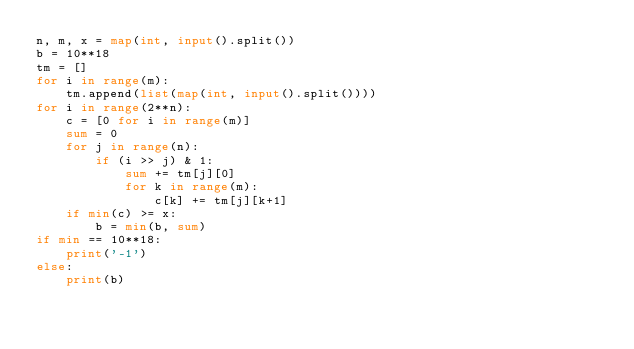Convert code to text. <code><loc_0><loc_0><loc_500><loc_500><_Python_>n, m, x = map(int, input().split())
b = 10**18
tm = []
for i in range(m):
    tm.append(list(map(int, input().split())))
for i in range(2**n):
    c = [0 for i in range(m)]
    sum = 0
    for j in range(n):
        if (i >> j) & 1:
            sum += tm[j][0]
            for k in range(m):
                c[k] += tm[j][k+1]
    if min(c) >= x:
        b = min(b, sum)
if min == 10**18:
    print('-1')
else:
    print(b)</code> 